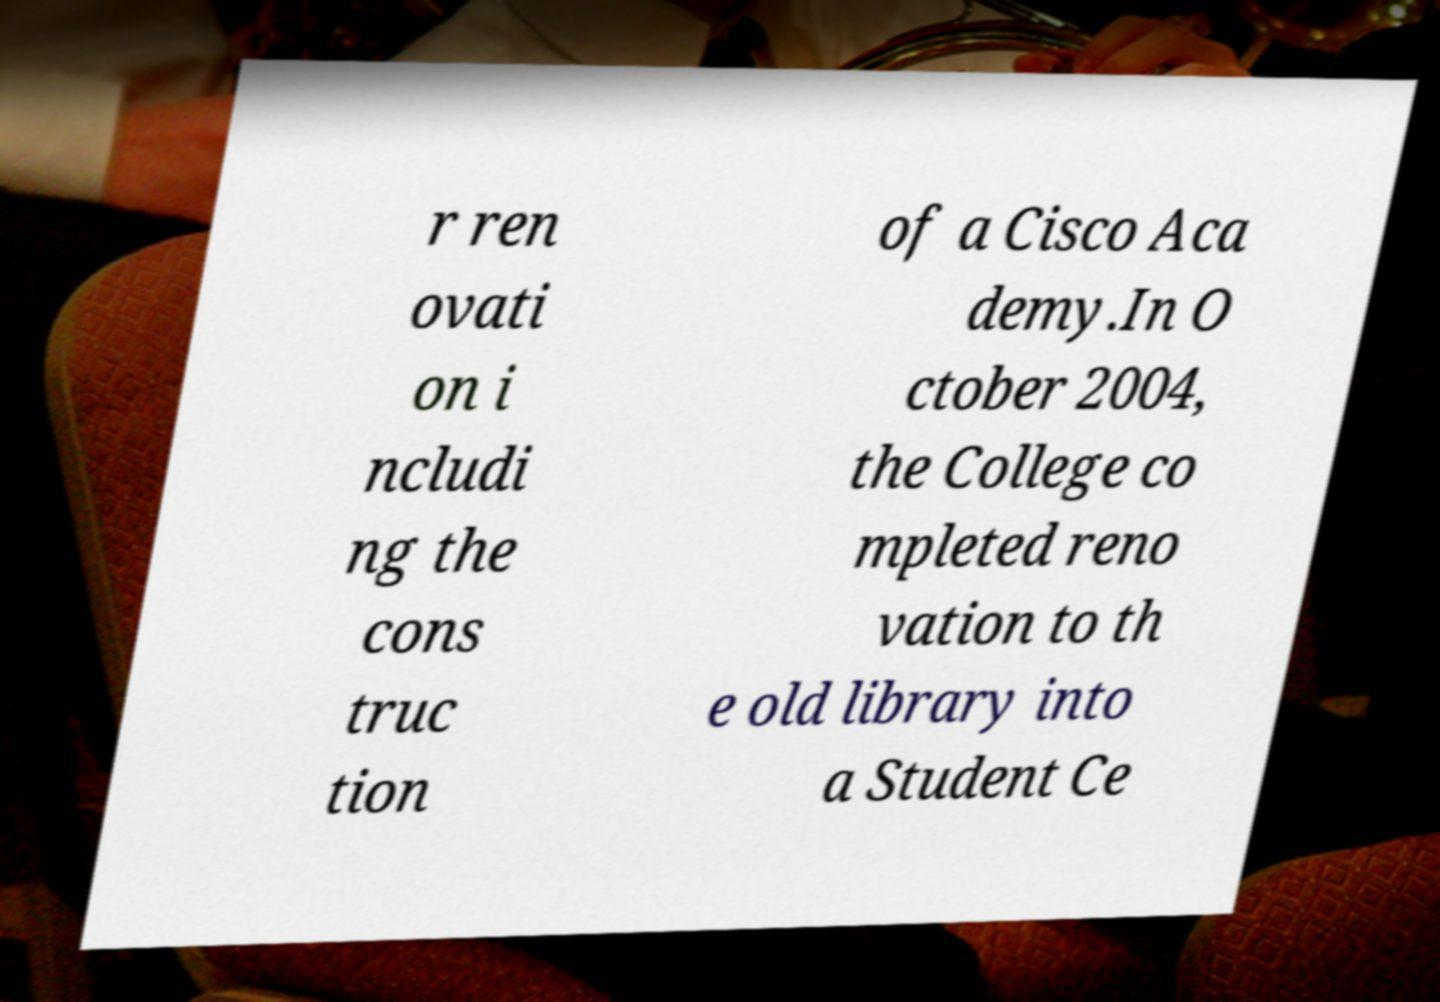For documentation purposes, I need the text within this image transcribed. Could you provide that? r ren ovati on i ncludi ng the cons truc tion of a Cisco Aca demy.In O ctober 2004, the College co mpleted reno vation to th e old library into a Student Ce 